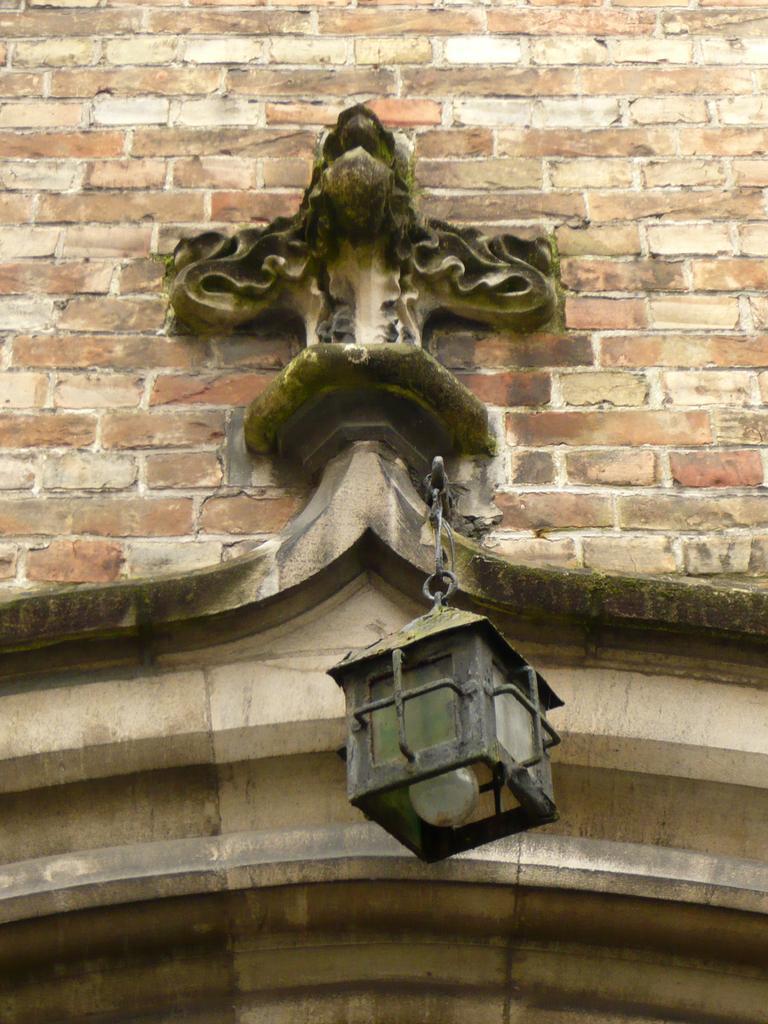Can you describe this image briefly? We can see a light is in an object which is hanging to a pole on the wall. 